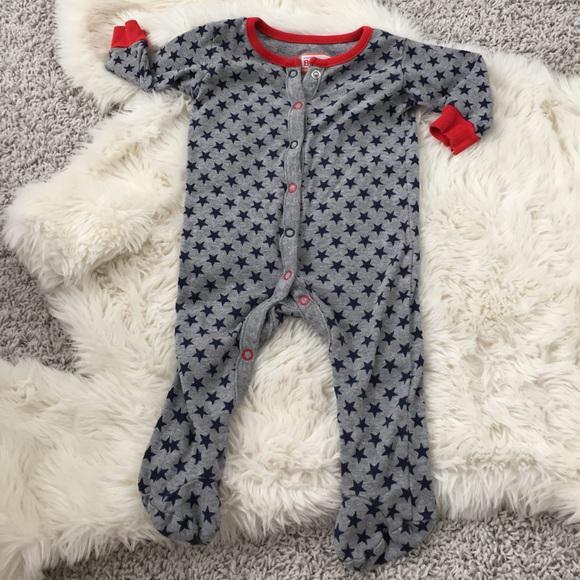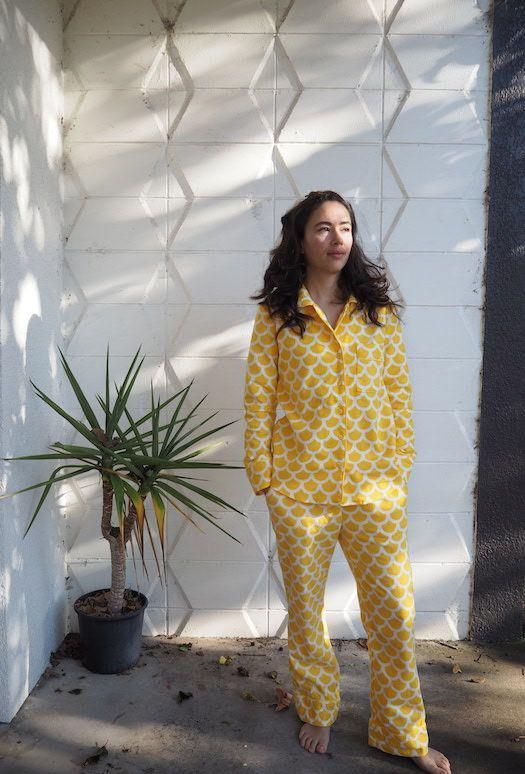The first image is the image on the left, the second image is the image on the right. Considering the images on both sides, is "A plant stands in the corner behind and to the left of a woman standing with hands in her pockets." valid? Answer yes or no. Yes. The first image is the image on the left, the second image is the image on the right. Considering the images on both sides, is "One image shows sleepwear displayed flat on a surface, instead of modeled by a person." valid? Answer yes or no. Yes. 